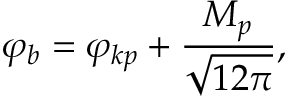Convert formula to latex. <formula><loc_0><loc_0><loc_500><loc_500>\varphi _ { b } = \varphi _ { k p } + \frac { M _ { p } } { \sqrt { 1 2 \pi } } ,</formula> 